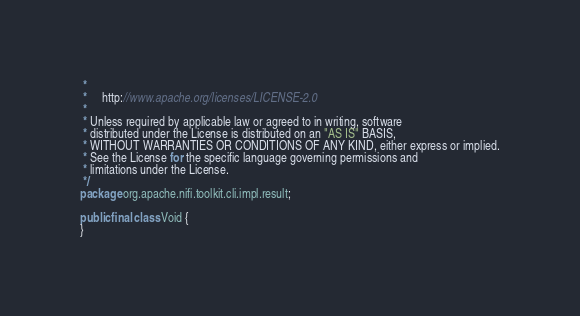Convert code to text. <code><loc_0><loc_0><loc_500><loc_500><_Java_> *
 *     http://www.apache.org/licenses/LICENSE-2.0
 *
 * Unless required by applicable law or agreed to in writing, software
 * distributed under the License is distributed on an "AS IS" BASIS,
 * WITHOUT WARRANTIES OR CONDITIONS OF ANY KIND, either express or implied.
 * See the License for the specific language governing permissions and
 * limitations under the License.
 */
package org.apache.nifi.toolkit.cli.impl.result;

public final class Void {
}
</code> 